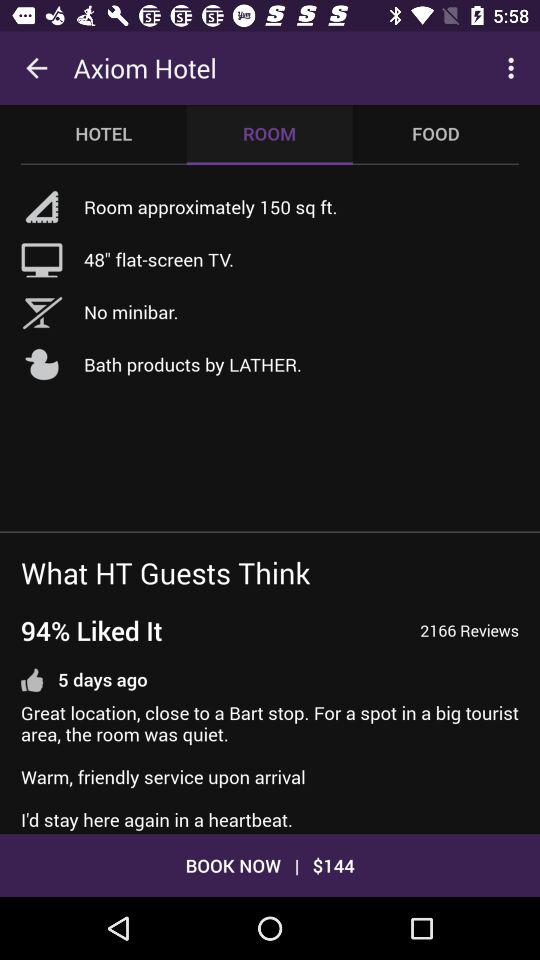Which days of the week are selected for staying at the hotel?
When the provided information is insufficient, respond with <no answer>. <no answer> 